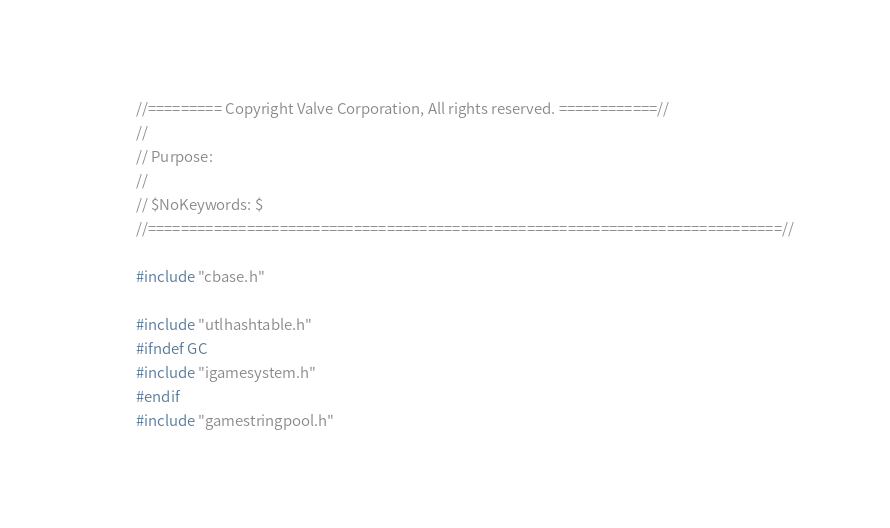Convert code to text. <code><loc_0><loc_0><loc_500><loc_500><_C++_>//========= Copyright Valve Corporation, All rights reserved. ============//
//
// Purpose:
//
// $NoKeywords: $
//=============================================================================//

#include "cbase.h"

#include "utlhashtable.h"
#ifndef GC
#include "igamesystem.h"
#endif
#include "gamestringpool.h"
</code> 